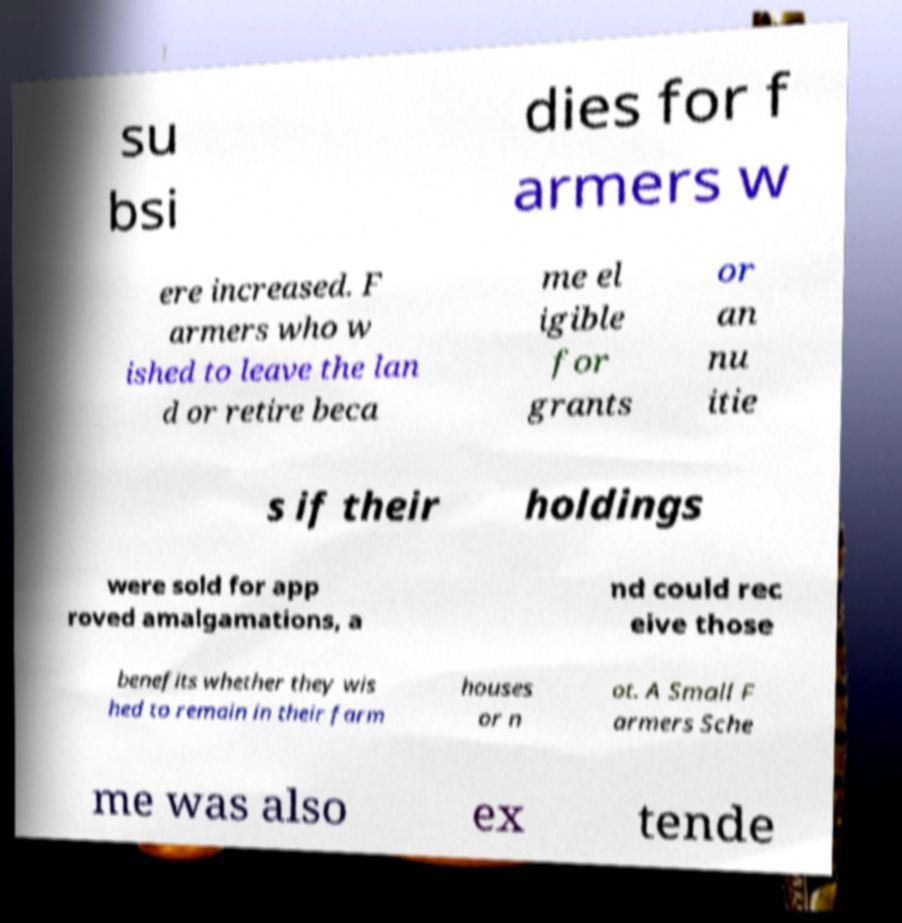Could you assist in decoding the text presented in this image and type it out clearly? su bsi dies for f armers w ere increased. F armers who w ished to leave the lan d or retire beca me el igible for grants or an nu itie s if their holdings were sold for app roved amalgamations, a nd could rec eive those benefits whether they wis hed to remain in their farm houses or n ot. A Small F armers Sche me was also ex tende 